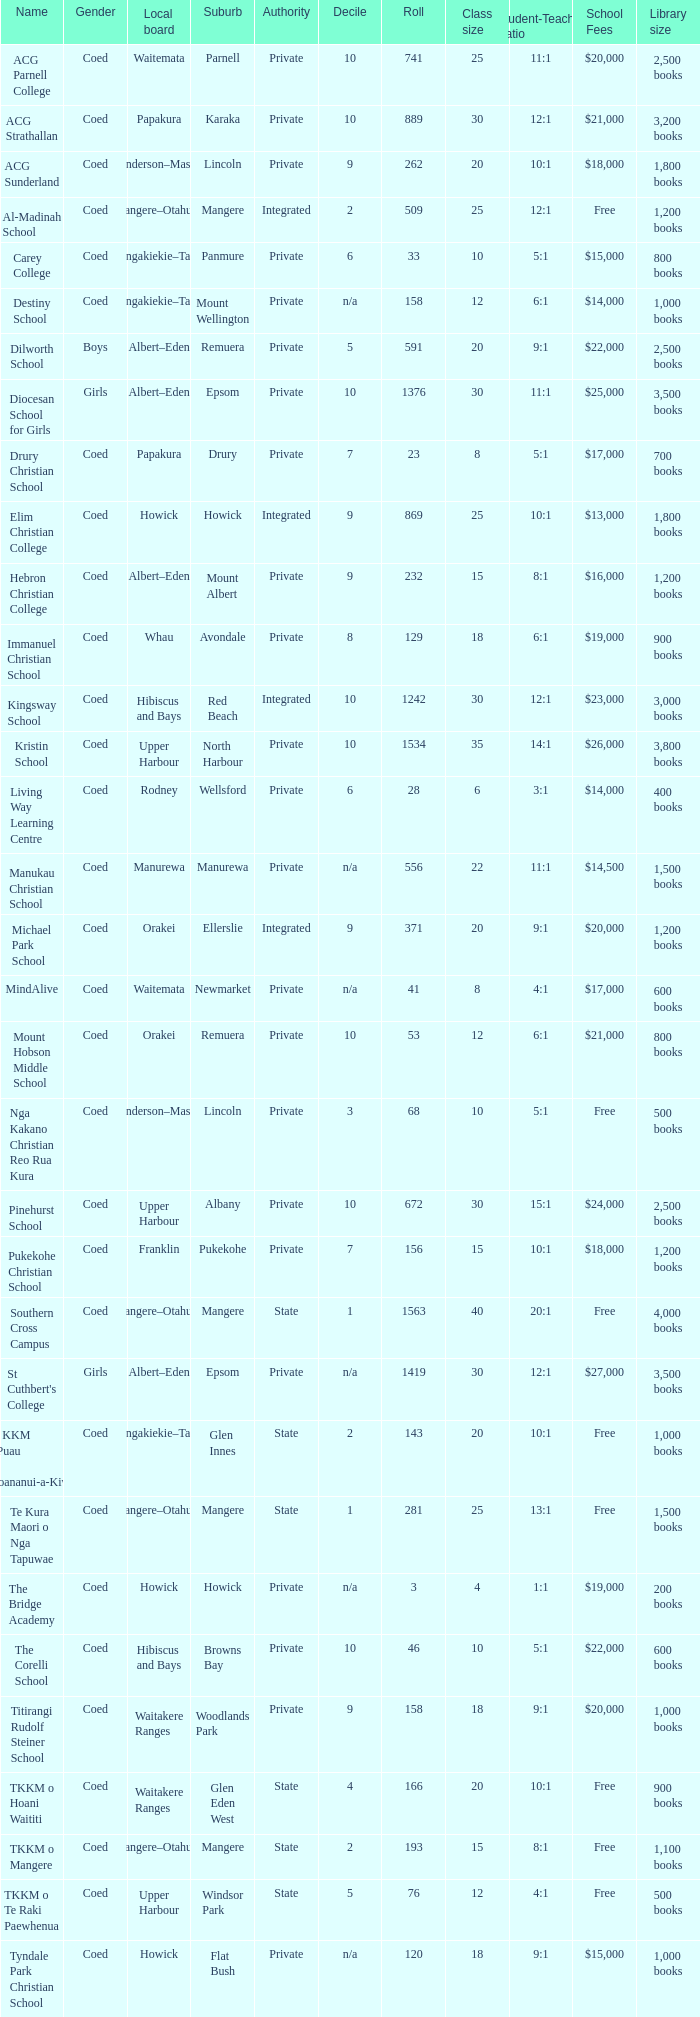What gender has a local board of albert–eden with a roll of more than 232 and Decile of 5? Boys. 